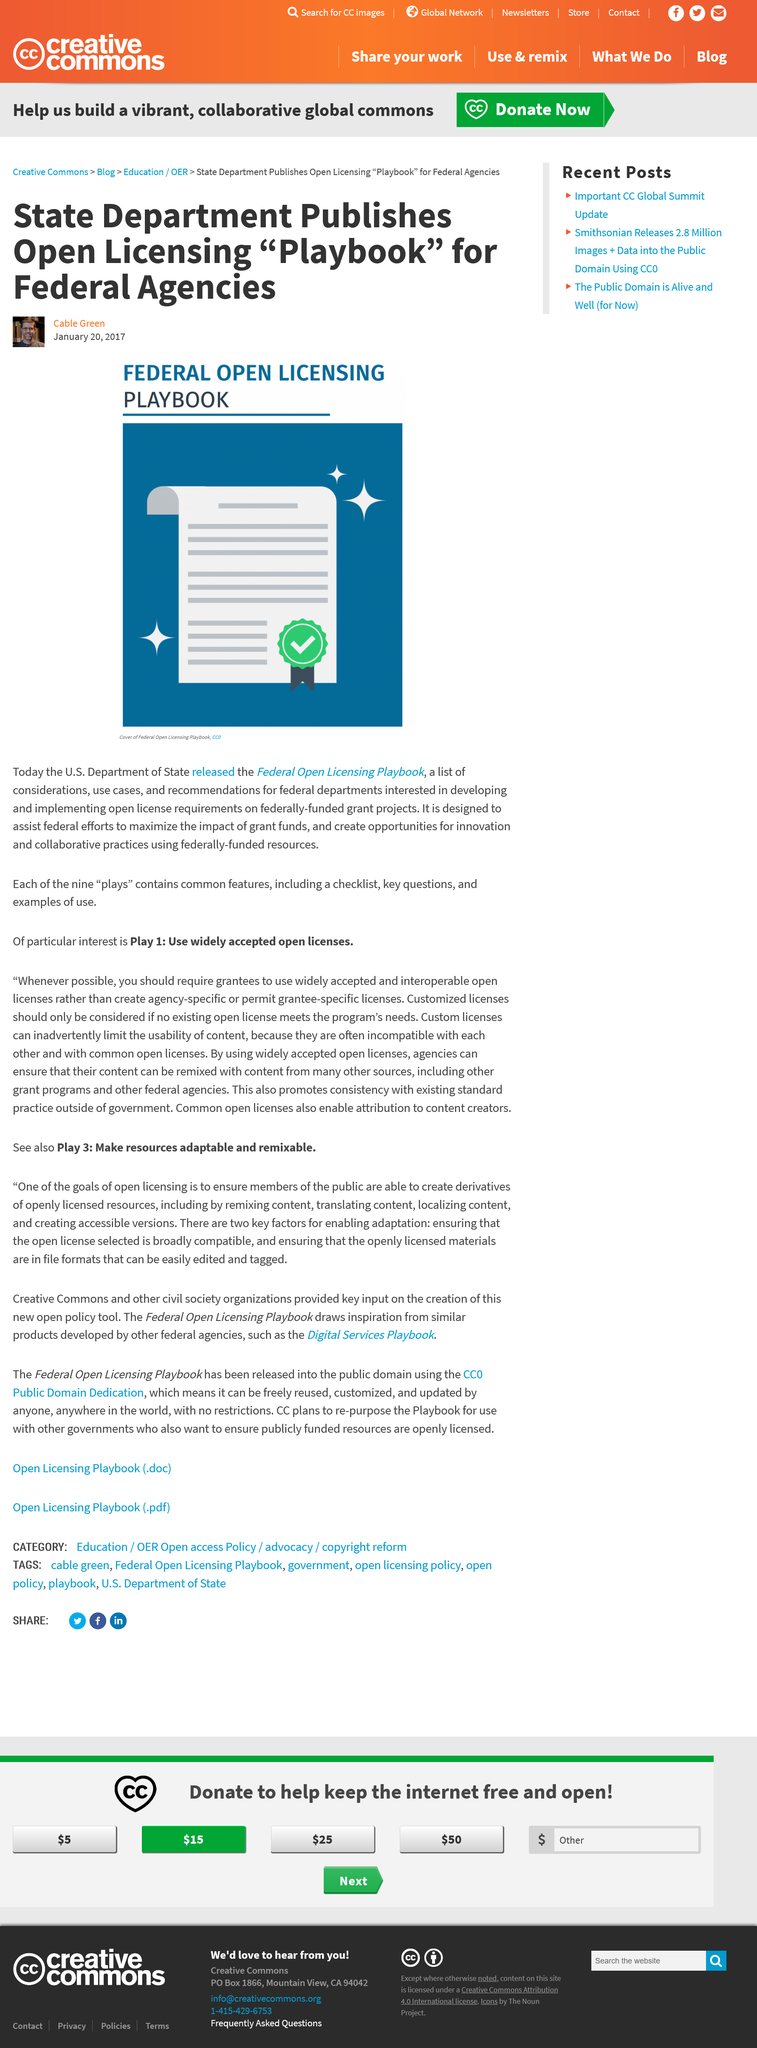Give some essential details in this illustration. The open licensing "playbook" is intended for use by federal agencies. The Federal Open Licensing Playbook is intended to facilitate the optimal use of grant funds by federal entities and promote innovative and collaborative practices by enabling the sharing of knowledge and resources. The U.S. Department of State released the Federal Open Licensing Playbook on January 20th, 2017. 